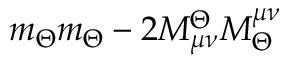<formula> <loc_0><loc_0><loc_500><loc_500>m _ { \Theta } m _ { \Theta } - 2 M _ { \mu \nu } ^ { \Theta } M _ { \Theta } ^ { \mu \nu }</formula> 